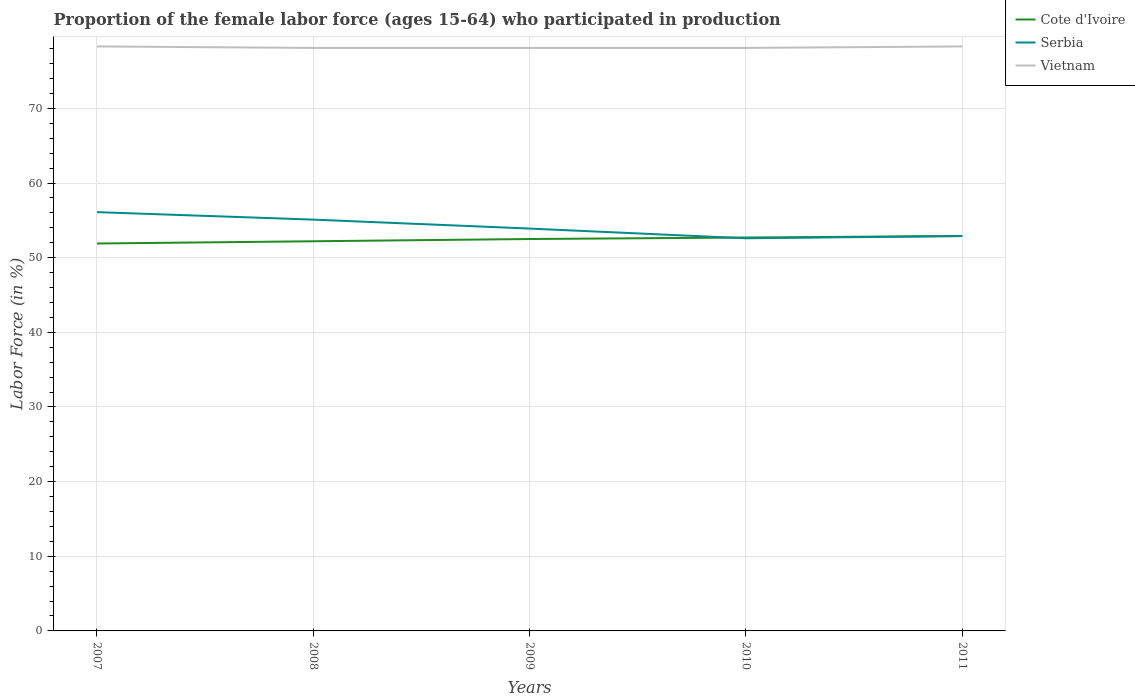Does the line corresponding to Vietnam intersect with the line corresponding to Serbia?
Keep it short and to the point. No. Is the number of lines equal to the number of legend labels?
Offer a very short reply. Yes. Across all years, what is the maximum proportion of the female labor force who participated in production in Vietnam?
Your response must be concise. 78.1. In which year was the proportion of the female labor force who participated in production in Vietnam maximum?
Offer a very short reply. 2008. What is the difference between the highest and the second highest proportion of the female labor force who participated in production in Vietnam?
Your response must be concise. 0.2. How many lines are there?
Your answer should be very brief. 3. How many years are there in the graph?
Give a very brief answer. 5. What is the difference between two consecutive major ticks on the Y-axis?
Offer a very short reply. 10. Are the values on the major ticks of Y-axis written in scientific E-notation?
Ensure brevity in your answer.  No. Does the graph contain any zero values?
Provide a succinct answer. No. Does the graph contain grids?
Ensure brevity in your answer.  Yes. Where does the legend appear in the graph?
Keep it short and to the point. Top right. How are the legend labels stacked?
Offer a terse response. Vertical. What is the title of the graph?
Your answer should be very brief. Proportion of the female labor force (ages 15-64) who participated in production. Does "Liechtenstein" appear as one of the legend labels in the graph?
Make the answer very short. No. What is the label or title of the Y-axis?
Your response must be concise. Labor Force (in %). What is the Labor Force (in %) in Cote d'Ivoire in 2007?
Your response must be concise. 51.9. What is the Labor Force (in %) in Serbia in 2007?
Provide a short and direct response. 56.1. What is the Labor Force (in %) of Vietnam in 2007?
Provide a succinct answer. 78.3. What is the Labor Force (in %) of Cote d'Ivoire in 2008?
Offer a very short reply. 52.2. What is the Labor Force (in %) of Serbia in 2008?
Give a very brief answer. 55.1. What is the Labor Force (in %) in Vietnam in 2008?
Offer a terse response. 78.1. What is the Labor Force (in %) of Cote d'Ivoire in 2009?
Your answer should be compact. 52.5. What is the Labor Force (in %) in Serbia in 2009?
Your response must be concise. 53.9. What is the Labor Force (in %) in Vietnam in 2009?
Ensure brevity in your answer.  78.1. What is the Labor Force (in %) in Cote d'Ivoire in 2010?
Your answer should be compact. 52.7. What is the Labor Force (in %) of Serbia in 2010?
Your response must be concise. 52.6. What is the Labor Force (in %) in Vietnam in 2010?
Your response must be concise. 78.1. What is the Labor Force (in %) of Cote d'Ivoire in 2011?
Give a very brief answer. 52.9. What is the Labor Force (in %) of Serbia in 2011?
Provide a short and direct response. 52.9. What is the Labor Force (in %) of Vietnam in 2011?
Your answer should be compact. 78.3. Across all years, what is the maximum Labor Force (in %) of Cote d'Ivoire?
Give a very brief answer. 52.9. Across all years, what is the maximum Labor Force (in %) in Serbia?
Your response must be concise. 56.1. Across all years, what is the maximum Labor Force (in %) in Vietnam?
Your answer should be compact. 78.3. Across all years, what is the minimum Labor Force (in %) in Cote d'Ivoire?
Give a very brief answer. 51.9. Across all years, what is the minimum Labor Force (in %) in Serbia?
Your answer should be very brief. 52.6. Across all years, what is the minimum Labor Force (in %) in Vietnam?
Offer a very short reply. 78.1. What is the total Labor Force (in %) of Cote d'Ivoire in the graph?
Give a very brief answer. 262.2. What is the total Labor Force (in %) of Serbia in the graph?
Offer a very short reply. 270.6. What is the total Labor Force (in %) of Vietnam in the graph?
Offer a terse response. 390.9. What is the difference between the Labor Force (in %) of Cote d'Ivoire in 2007 and that in 2008?
Your response must be concise. -0.3. What is the difference between the Labor Force (in %) in Cote d'Ivoire in 2007 and that in 2009?
Keep it short and to the point. -0.6. What is the difference between the Labor Force (in %) of Vietnam in 2007 and that in 2009?
Provide a short and direct response. 0.2. What is the difference between the Labor Force (in %) in Cote d'Ivoire in 2007 and that in 2010?
Your response must be concise. -0.8. What is the difference between the Labor Force (in %) in Vietnam in 2007 and that in 2010?
Offer a very short reply. 0.2. What is the difference between the Labor Force (in %) of Serbia in 2007 and that in 2011?
Your answer should be very brief. 3.2. What is the difference between the Labor Force (in %) of Vietnam in 2008 and that in 2009?
Give a very brief answer. 0. What is the difference between the Labor Force (in %) in Cote d'Ivoire in 2008 and that in 2011?
Give a very brief answer. -0.7. What is the difference between the Labor Force (in %) of Cote d'Ivoire in 2009 and that in 2010?
Provide a succinct answer. -0.2. What is the difference between the Labor Force (in %) of Vietnam in 2009 and that in 2010?
Give a very brief answer. 0. What is the difference between the Labor Force (in %) of Cote d'Ivoire in 2009 and that in 2011?
Offer a very short reply. -0.4. What is the difference between the Labor Force (in %) of Serbia in 2009 and that in 2011?
Your response must be concise. 1. What is the difference between the Labor Force (in %) of Vietnam in 2009 and that in 2011?
Ensure brevity in your answer.  -0.2. What is the difference between the Labor Force (in %) in Cote d'Ivoire in 2010 and that in 2011?
Keep it short and to the point. -0.2. What is the difference between the Labor Force (in %) of Serbia in 2010 and that in 2011?
Offer a terse response. -0.3. What is the difference between the Labor Force (in %) in Vietnam in 2010 and that in 2011?
Your response must be concise. -0.2. What is the difference between the Labor Force (in %) in Cote d'Ivoire in 2007 and the Labor Force (in %) in Serbia in 2008?
Your answer should be very brief. -3.2. What is the difference between the Labor Force (in %) of Cote d'Ivoire in 2007 and the Labor Force (in %) of Vietnam in 2008?
Your response must be concise. -26.2. What is the difference between the Labor Force (in %) in Cote d'Ivoire in 2007 and the Labor Force (in %) in Serbia in 2009?
Offer a terse response. -2. What is the difference between the Labor Force (in %) in Cote d'Ivoire in 2007 and the Labor Force (in %) in Vietnam in 2009?
Offer a very short reply. -26.2. What is the difference between the Labor Force (in %) of Serbia in 2007 and the Labor Force (in %) of Vietnam in 2009?
Provide a succinct answer. -22. What is the difference between the Labor Force (in %) of Cote d'Ivoire in 2007 and the Labor Force (in %) of Vietnam in 2010?
Your answer should be compact. -26.2. What is the difference between the Labor Force (in %) in Cote d'Ivoire in 2007 and the Labor Force (in %) in Vietnam in 2011?
Give a very brief answer. -26.4. What is the difference between the Labor Force (in %) in Serbia in 2007 and the Labor Force (in %) in Vietnam in 2011?
Provide a succinct answer. -22.2. What is the difference between the Labor Force (in %) of Cote d'Ivoire in 2008 and the Labor Force (in %) of Serbia in 2009?
Your response must be concise. -1.7. What is the difference between the Labor Force (in %) of Cote d'Ivoire in 2008 and the Labor Force (in %) of Vietnam in 2009?
Your response must be concise. -25.9. What is the difference between the Labor Force (in %) of Serbia in 2008 and the Labor Force (in %) of Vietnam in 2009?
Keep it short and to the point. -23. What is the difference between the Labor Force (in %) of Cote d'Ivoire in 2008 and the Labor Force (in %) of Serbia in 2010?
Make the answer very short. -0.4. What is the difference between the Labor Force (in %) of Cote d'Ivoire in 2008 and the Labor Force (in %) of Vietnam in 2010?
Provide a short and direct response. -25.9. What is the difference between the Labor Force (in %) in Serbia in 2008 and the Labor Force (in %) in Vietnam in 2010?
Your answer should be compact. -23. What is the difference between the Labor Force (in %) of Cote d'Ivoire in 2008 and the Labor Force (in %) of Vietnam in 2011?
Ensure brevity in your answer.  -26.1. What is the difference between the Labor Force (in %) of Serbia in 2008 and the Labor Force (in %) of Vietnam in 2011?
Provide a short and direct response. -23.2. What is the difference between the Labor Force (in %) in Cote d'Ivoire in 2009 and the Labor Force (in %) in Serbia in 2010?
Keep it short and to the point. -0.1. What is the difference between the Labor Force (in %) in Cote d'Ivoire in 2009 and the Labor Force (in %) in Vietnam in 2010?
Provide a succinct answer. -25.6. What is the difference between the Labor Force (in %) in Serbia in 2009 and the Labor Force (in %) in Vietnam in 2010?
Make the answer very short. -24.2. What is the difference between the Labor Force (in %) of Cote d'Ivoire in 2009 and the Labor Force (in %) of Vietnam in 2011?
Offer a very short reply. -25.8. What is the difference between the Labor Force (in %) in Serbia in 2009 and the Labor Force (in %) in Vietnam in 2011?
Provide a short and direct response. -24.4. What is the difference between the Labor Force (in %) of Cote d'Ivoire in 2010 and the Labor Force (in %) of Serbia in 2011?
Give a very brief answer. -0.2. What is the difference between the Labor Force (in %) of Cote d'Ivoire in 2010 and the Labor Force (in %) of Vietnam in 2011?
Your answer should be compact. -25.6. What is the difference between the Labor Force (in %) in Serbia in 2010 and the Labor Force (in %) in Vietnam in 2011?
Ensure brevity in your answer.  -25.7. What is the average Labor Force (in %) in Cote d'Ivoire per year?
Keep it short and to the point. 52.44. What is the average Labor Force (in %) of Serbia per year?
Provide a succinct answer. 54.12. What is the average Labor Force (in %) in Vietnam per year?
Ensure brevity in your answer.  78.18. In the year 2007, what is the difference between the Labor Force (in %) of Cote d'Ivoire and Labor Force (in %) of Vietnam?
Offer a very short reply. -26.4. In the year 2007, what is the difference between the Labor Force (in %) in Serbia and Labor Force (in %) in Vietnam?
Ensure brevity in your answer.  -22.2. In the year 2008, what is the difference between the Labor Force (in %) in Cote d'Ivoire and Labor Force (in %) in Serbia?
Your answer should be compact. -2.9. In the year 2008, what is the difference between the Labor Force (in %) in Cote d'Ivoire and Labor Force (in %) in Vietnam?
Your answer should be very brief. -25.9. In the year 2008, what is the difference between the Labor Force (in %) of Serbia and Labor Force (in %) of Vietnam?
Provide a short and direct response. -23. In the year 2009, what is the difference between the Labor Force (in %) in Cote d'Ivoire and Labor Force (in %) in Vietnam?
Ensure brevity in your answer.  -25.6. In the year 2009, what is the difference between the Labor Force (in %) of Serbia and Labor Force (in %) of Vietnam?
Keep it short and to the point. -24.2. In the year 2010, what is the difference between the Labor Force (in %) of Cote d'Ivoire and Labor Force (in %) of Vietnam?
Offer a terse response. -25.4. In the year 2010, what is the difference between the Labor Force (in %) of Serbia and Labor Force (in %) of Vietnam?
Give a very brief answer. -25.5. In the year 2011, what is the difference between the Labor Force (in %) of Cote d'Ivoire and Labor Force (in %) of Serbia?
Make the answer very short. 0. In the year 2011, what is the difference between the Labor Force (in %) in Cote d'Ivoire and Labor Force (in %) in Vietnam?
Provide a succinct answer. -25.4. In the year 2011, what is the difference between the Labor Force (in %) in Serbia and Labor Force (in %) in Vietnam?
Offer a very short reply. -25.4. What is the ratio of the Labor Force (in %) in Cote d'Ivoire in 2007 to that in 2008?
Offer a very short reply. 0.99. What is the ratio of the Labor Force (in %) in Serbia in 2007 to that in 2008?
Your answer should be very brief. 1.02. What is the ratio of the Labor Force (in %) of Serbia in 2007 to that in 2009?
Provide a short and direct response. 1.04. What is the ratio of the Labor Force (in %) in Vietnam in 2007 to that in 2009?
Your answer should be very brief. 1. What is the ratio of the Labor Force (in %) of Cote d'Ivoire in 2007 to that in 2010?
Keep it short and to the point. 0.98. What is the ratio of the Labor Force (in %) of Serbia in 2007 to that in 2010?
Ensure brevity in your answer.  1.07. What is the ratio of the Labor Force (in %) of Vietnam in 2007 to that in 2010?
Offer a very short reply. 1. What is the ratio of the Labor Force (in %) of Cote d'Ivoire in 2007 to that in 2011?
Provide a succinct answer. 0.98. What is the ratio of the Labor Force (in %) of Serbia in 2007 to that in 2011?
Keep it short and to the point. 1.06. What is the ratio of the Labor Force (in %) of Cote d'Ivoire in 2008 to that in 2009?
Offer a very short reply. 0.99. What is the ratio of the Labor Force (in %) of Serbia in 2008 to that in 2009?
Provide a short and direct response. 1.02. What is the ratio of the Labor Force (in %) in Serbia in 2008 to that in 2010?
Provide a succinct answer. 1.05. What is the ratio of the Labor Force (in %) of Cote d'Ivoire in 2008 to that in 2011?
Provide a succinct answer. 0.99. What is the ratio of the Labor Force (in %) of Serbia in 2008 to that in 2011?
Provide a short and direct response. 1.04. What is the ratio of the Labor Force (in %) in Vietnam in 2008 to that in 2011?
Give a very brief answer. 1. What is the ratio of the Labor Force (in %) of Serbia in 2009 to that in 2010?
Ensure brevity in your answer.  1.02. What is the ratio of the Labor Force (in %) of Vietnam in 2009 to that in 2010?
Provide a short and direct response. 1. What is the ratio of the Labor Force (in %) of Cote d'Ivoire in 2009 to that in 2011?
Provide a short and direct response. 0.99. What is the ratio of the Labor Force (in %) of Serbia in 2009 to that in 2011?
Keep it short and to the point. 1.02. What is the ratio of the Labor Force (in %) of Vietnam in 2009 to that in 2011?
Offer a very short reply. 1. What is the ratio of the Labor Force (in %) in Vietnam in 2010 to that in 2011?
Offer a terse response. 1. What is the difference between the highest and the second highest Labor Force (in %) of Cote d'Ivoire?
Your response must be concise. 0.2. What is the difference between the highest and the second highest Labor Force (in %) of Serbia?
Give a very brief answer. 1. What is the difference between the highest and the lowest Labor Force (in %) in Cote d'Ivoire?
Provide a succinct answer. 1. What is the difference between the highest and the lowest Labor Force (in %) in Serbia?
Your answer should be compact. 3.5. 